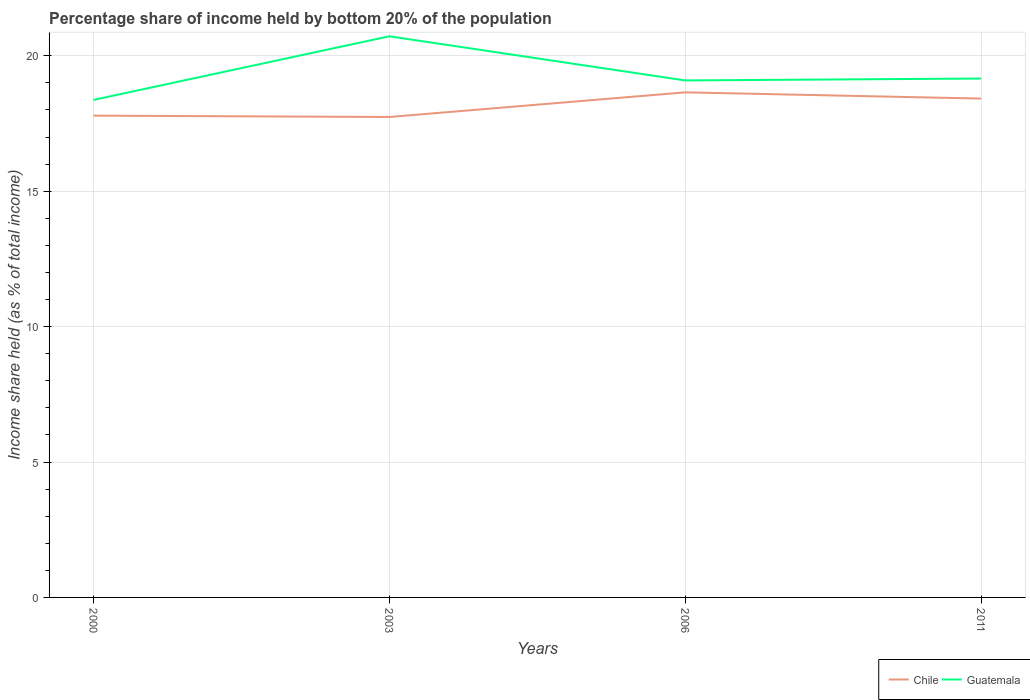How many different coloured lines are there?
Give a very brief answer. 2. Does the line corresponding to Chile intersect with the line corresponding to Guatemala?
Provide a short and direct response. No. Across all years, what is the maximum share of income held by bottom 20% of the population in Chile?
Give a very brief answer. 17.74. What is the total share of income held by bottom 20% of the population in Chile in the graph?
Offer a very short reply. 0.23. What is the difference between the highest and the second highest share of income held by bottom 20% of the population in Guatemala?
Your answer should be very brief. 2.35. What is the difference between the highest and the lowest share of income held by bottom 20% of the population in Chile?
Your answer should be compact. 2. How many years are there in the graph?
Your answer should be very brief. 4. Are the values on the major ticks of Y-axis written in scientific E-notation?
Give a very brief answer. No. Where does the legend appear in the graph?
Keep it short and to the point. Bottom right. What is the title of the graph?
Give a very brief answer. Percentage share of income held by bottom 20% of the population. What is the label or title of the Y-axis?
Offer a terse response. Income share held (as % of total income). What is the Income share held (as % of total income) of Chile in 2000?
Give a very brief answer. 17.79. What is the Income share held (as % of total income) in Guatemala in 2000?
Offer a very short reply. 18.37. What is the Income share held (as % of total income) in Chile in 2003?
Your answer should be compact. 17.74. What is the Income share held (as % of total income) in Guatemala in 2003?
Make the answer very short. 20.72. What is the Income share held (as % of total income) in Chile in 2006?
Your answer should be very brief. 18.65. What is the Income share held (as % of total income) of Guatemala in 2006?
Give a very brief answer. 19.09. What is the Income share held (as % of total income) in Chile in 2011?
Offer a terse response. 18.42. What is the Income share held (as % of total income) in Guatemala in 2011?
Offer a terse response. 19.16. Across all years, what is the maximum Income share held (as % of total income) of Chile?
Keep it short and to the point. 18.65. Across all years, what is the maximum Income share held (as % of total income) of Guatemala?
Provide a short and direct response. 20.72. Across all years, what is the minimum Income share held (as % of total income) in Chile?
Offer a very short reply. 17.74. Across all years, what is the minimum Income share held (as % of total income) of Guatemala?
Give a very brief answer. 18.37. What is the total Income share held (as % of total income) in Chile in the graph?
Give a very brief answer. 72.6. What is the total Income share held (as % of total income) of Guatemala in the graph?
Offer a very short reply. 77.34. What is the difference between the Income share held (as % of total income) of Guatemala in 2000 and that in 2003?
Keep it short and to the point. -2.35. What is the difference between the Income share held (as % of total income) of Chile in 2000 and that in 2006?
Ensure brevity in your answer.  -0.86. What is the difference between the Income share held (as % of total income) in Guatemala in 2000 and that in 2006?
Give a very brief answer. -0.72. What is the difference between the Income share held (as % of total income) in Chile in 2000 and that in 2011?
Ensure brevity in your answer.  -0.63. What is the difference between the Income share held (as % of total income) in Guatemala in 2000 and that in 2011?
Offer a very short reply. -0.79. What is the difference between the Income share held (as % of total income) of Chile in 2003 and that in 2006?
Offer a terse response. -0.91. What is the difference between the Income share held (as % of total income) of Guatemala in 2003 and that in 2006?
Offer a terse response. 1.63. What is the difference between the Income share held (as % of total income) of Chile in 2003 and that in 2011?
Your response must be concise. -0.68. What is the difference between the Income share held (as % of total income) in Guatemala in 2003 and that in 2011?
Make the answer very short. 1.56. What is the difference between the Income share held (as % of total income) of Chile in 2006 and that in 2011?
Provide a succinct answer. 0.23. What is the difference between the Income share held (as % of total income) in Guatemala in 2006 and that in 2011?
Your answer should be very brief. -0.07. What is the difference between the Income share held (as % of total income) in Chile in 2000 and the Income share held (as % of total income) in Guatemala in 2003?
Offer a very short reply. -2.93. What is the difference between the Income share held (as % of total income) in Chile in 2000 and the Income share held (as % of total income) in Guatemala in 2011?
Keep it short and to the point. -1.37. What is the difference between the Income share held (as % of total income) of Chile in 2003 and the Income share held (as % of total income) of Guatemala in 2006?
Your answer should be very brief. -1.35. What is the difference between the Income share held (as % of total income) of Chile in 2003 and the Income share held (as % of total income) of Guatemala in 2011?
Your answer should be compact. -1.42. What is the difference between the Income share held (as % of total income) in Chile in 2006 and the Income share held (as % of total income) in Guatemala in 2011?
Ensure brevity in your answer.  -0.51. What is the average Income share held (as % of total income) of Chile per year?
Provide a short and direct response. 18.15. What is the average Income share held (as % of total income) in Guatemala per year?
Ensure brevity in your answer.  19.34. In the year 2000, what is the difference between the Income share held (as % of total income) in Chile and Income share held (as % of total income) in Guatemala?
Provide a succinct answer. -0.58. In the year 2003, what is the difference between the Income share held (as % of total income) of Chile and Income share held (as % of total income) of Guatemala?
Offer a terse response. -2.98. In the year 2006, what is the difference between the Income share held (as % of total income) in Chile and Income share held (as % of total income) in Guatemala?
Provide a succinct answer. -0.44. In the year 2011, what is the difference between the Income share held (as % of total income) of Chile and Income share held (as % of total income) of Guatemala?
Offer a very short reply. -0.74. What is the ratio of the Income share held (as % of total income) in Guatemala in 2000 to that in 2003?
Offer a terse response. 0.89. What is the ratio of the Income share held (as % of total income) of Chile in 2000 to that in 2006?
Offer a very short reply. 0.95. What is the ratio of the Income share held (as % of total income) of Guatemala in 2000 to that in 2006?
Keep it short and to the point. 0.96. What is the ratio of the Income share held (as % of total income) of Chile in 2000 to that in 2011?
Keep it short and to the point. 0.97. What is the ratio of the Income share held (as % of total income) of Guatemala in 2000 to that in 2011?
Offer a very short reply. 0.96. What is the ratio of the Income share held (as % of total income) of Chile in 2003 to that in 2006?
Make the answer very short. 0.95. What is the ratio of the Income share held (as % of total income) of Guatemala in 2003 to that in 2006?
Offer a very short reply. 1.09. What is the ratio of the Income share held (as % of total income) of Chile in 2003 to that in 2011?
Keep it short and to the point. 0.96. What is the ratio of the Income share held (as % of total income) of Guatemala in 2003 to that in 2011?
Provide a short and direct response. 1.08. What is the ratio of the Income share held (as % of total income) in Chile in 2006 to that in 2011?
Your answer should be very brief. 1.01. What is the ratio of the Income share held (as % of total income) of Guatemala in 2006 to that in 2011?
Your answer should be very brief. 1. What is the difference between the highest and the second highest Income share held (as % of total income) in Chile?
Offer a very short reply. 0.23. What is the difference between the highest and the second highest Income share held (as % of total income) of Guatemala?
Give a very brief answer. 1.56. What is the difference between the highest and the lowest Income share held (as % of total income) in Chile?
Your answer should be very brief. 0.91. What is the difference between the highest and the lowest Income share held (as % of total income) in Guatemala?
Offer a terse response. 2.35. 